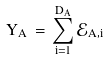Convert formula to latex. <formula><loc_0><loc_0><loc_500><loc_500>Y _ { A } \, = \, \sum _ { i = 1 } ^ { D _ { A } } \mathcal { E } _ { A , i }</formula> 